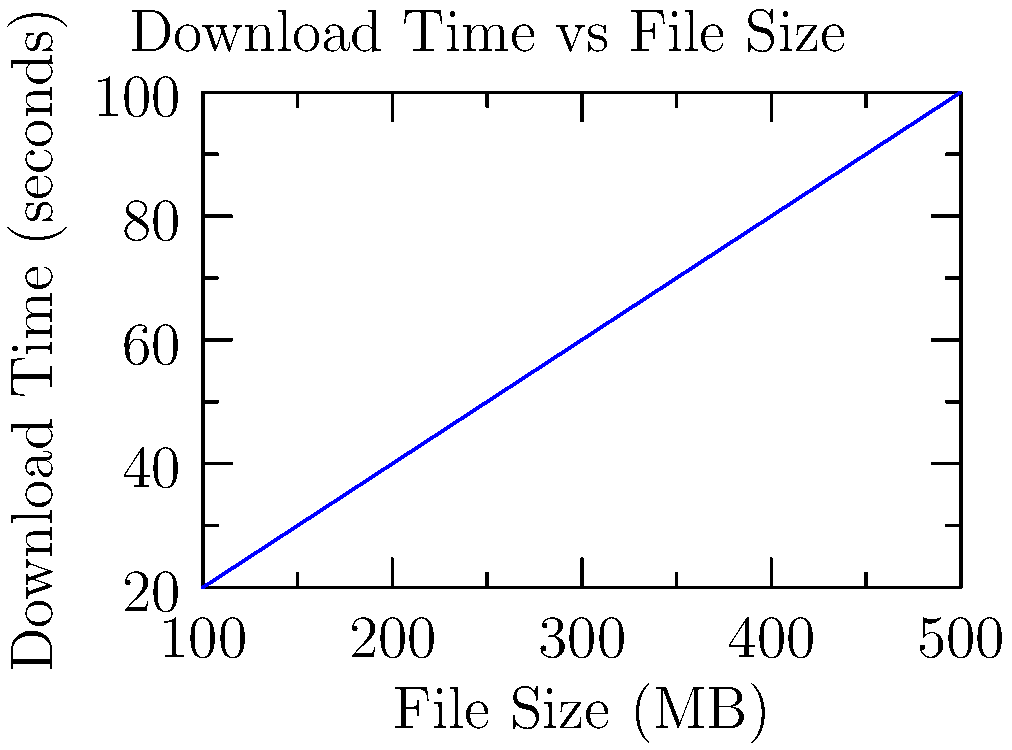As a web developer, you're tasked with optimizing a file download system. The graph shows the relationship between file size and download time. If a user has an internet speed of $5$ MB/s, how long would it take to download a $250$ MB file? To solve this problem, we'll follow these steps:

1. Understand the given information:
   - Internet speed = $5$ MB/s
   - File size = $250$ MB

2. Calculate the download time:
   - Time = File size ÷ Internet speed
   - Time = $250$ MB ÷ $5$ MB/s
   - Time = $50$ seconds

3. Verify with the graph:
   - Locate $250$ MB on the x-axis
   - Follow the line up to the curve
   - Read the corresponding value on the y-axis

The graph confirms that a $250$ MB file would take approximately $50$ seconds to download, which matches our calculation.
Answer: $50$ seconds 